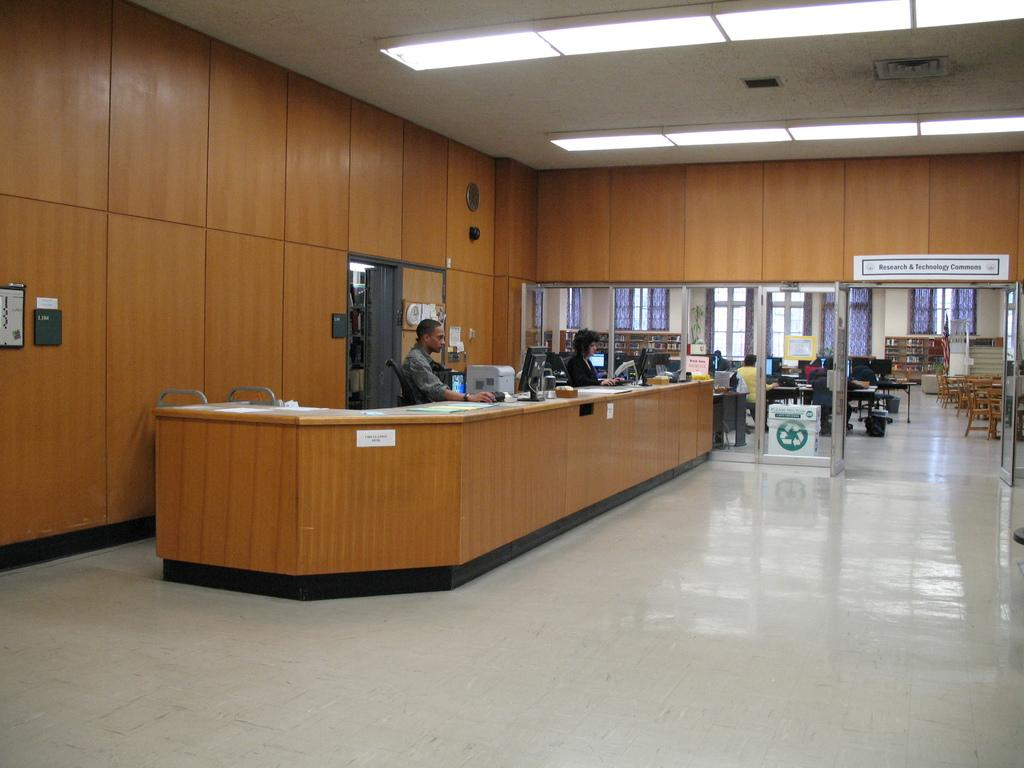How many people are in the image? There are two persons in the image. What are the two persons doing in the image? They are sitting on a chair and working on a computer. What type of door can be seen in the image? There is a glass door in the image. What is the purpose of the glass door? The glass door is used to enter the room. What furniture is available in the room? A table and chairs are present in the room. How many boys are sleeping in the image? There is no boy present in the image, and no one is sleeping. 